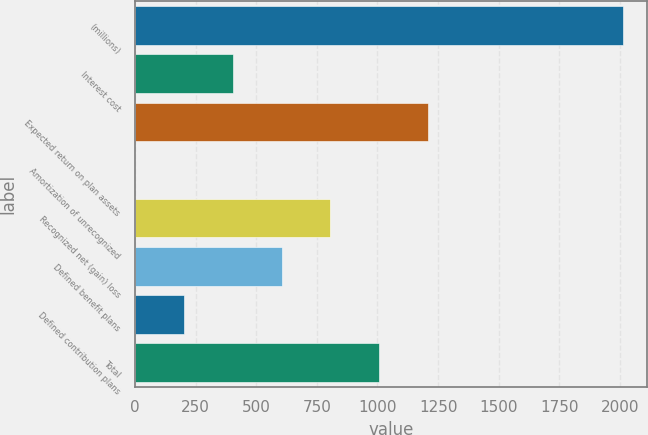Convert chart. <chart><loc_0><loc_0><loc_500><loc_500><bar_chart><fcel>(millions)<fcel>Interest cost<fcel>Expected return on plan assets<fcel>Amortization of unrecognized<fcel>Recognized net (gain) loss<fcel>Defined benefit plans<fcel>Defined contribution plans<fcel>Total<nl><fcel>2012<fcel>404<fcel>1208<fcel>2<fcel>806<fcel>605<fcel>203<fcel>1007<nl></chart> 